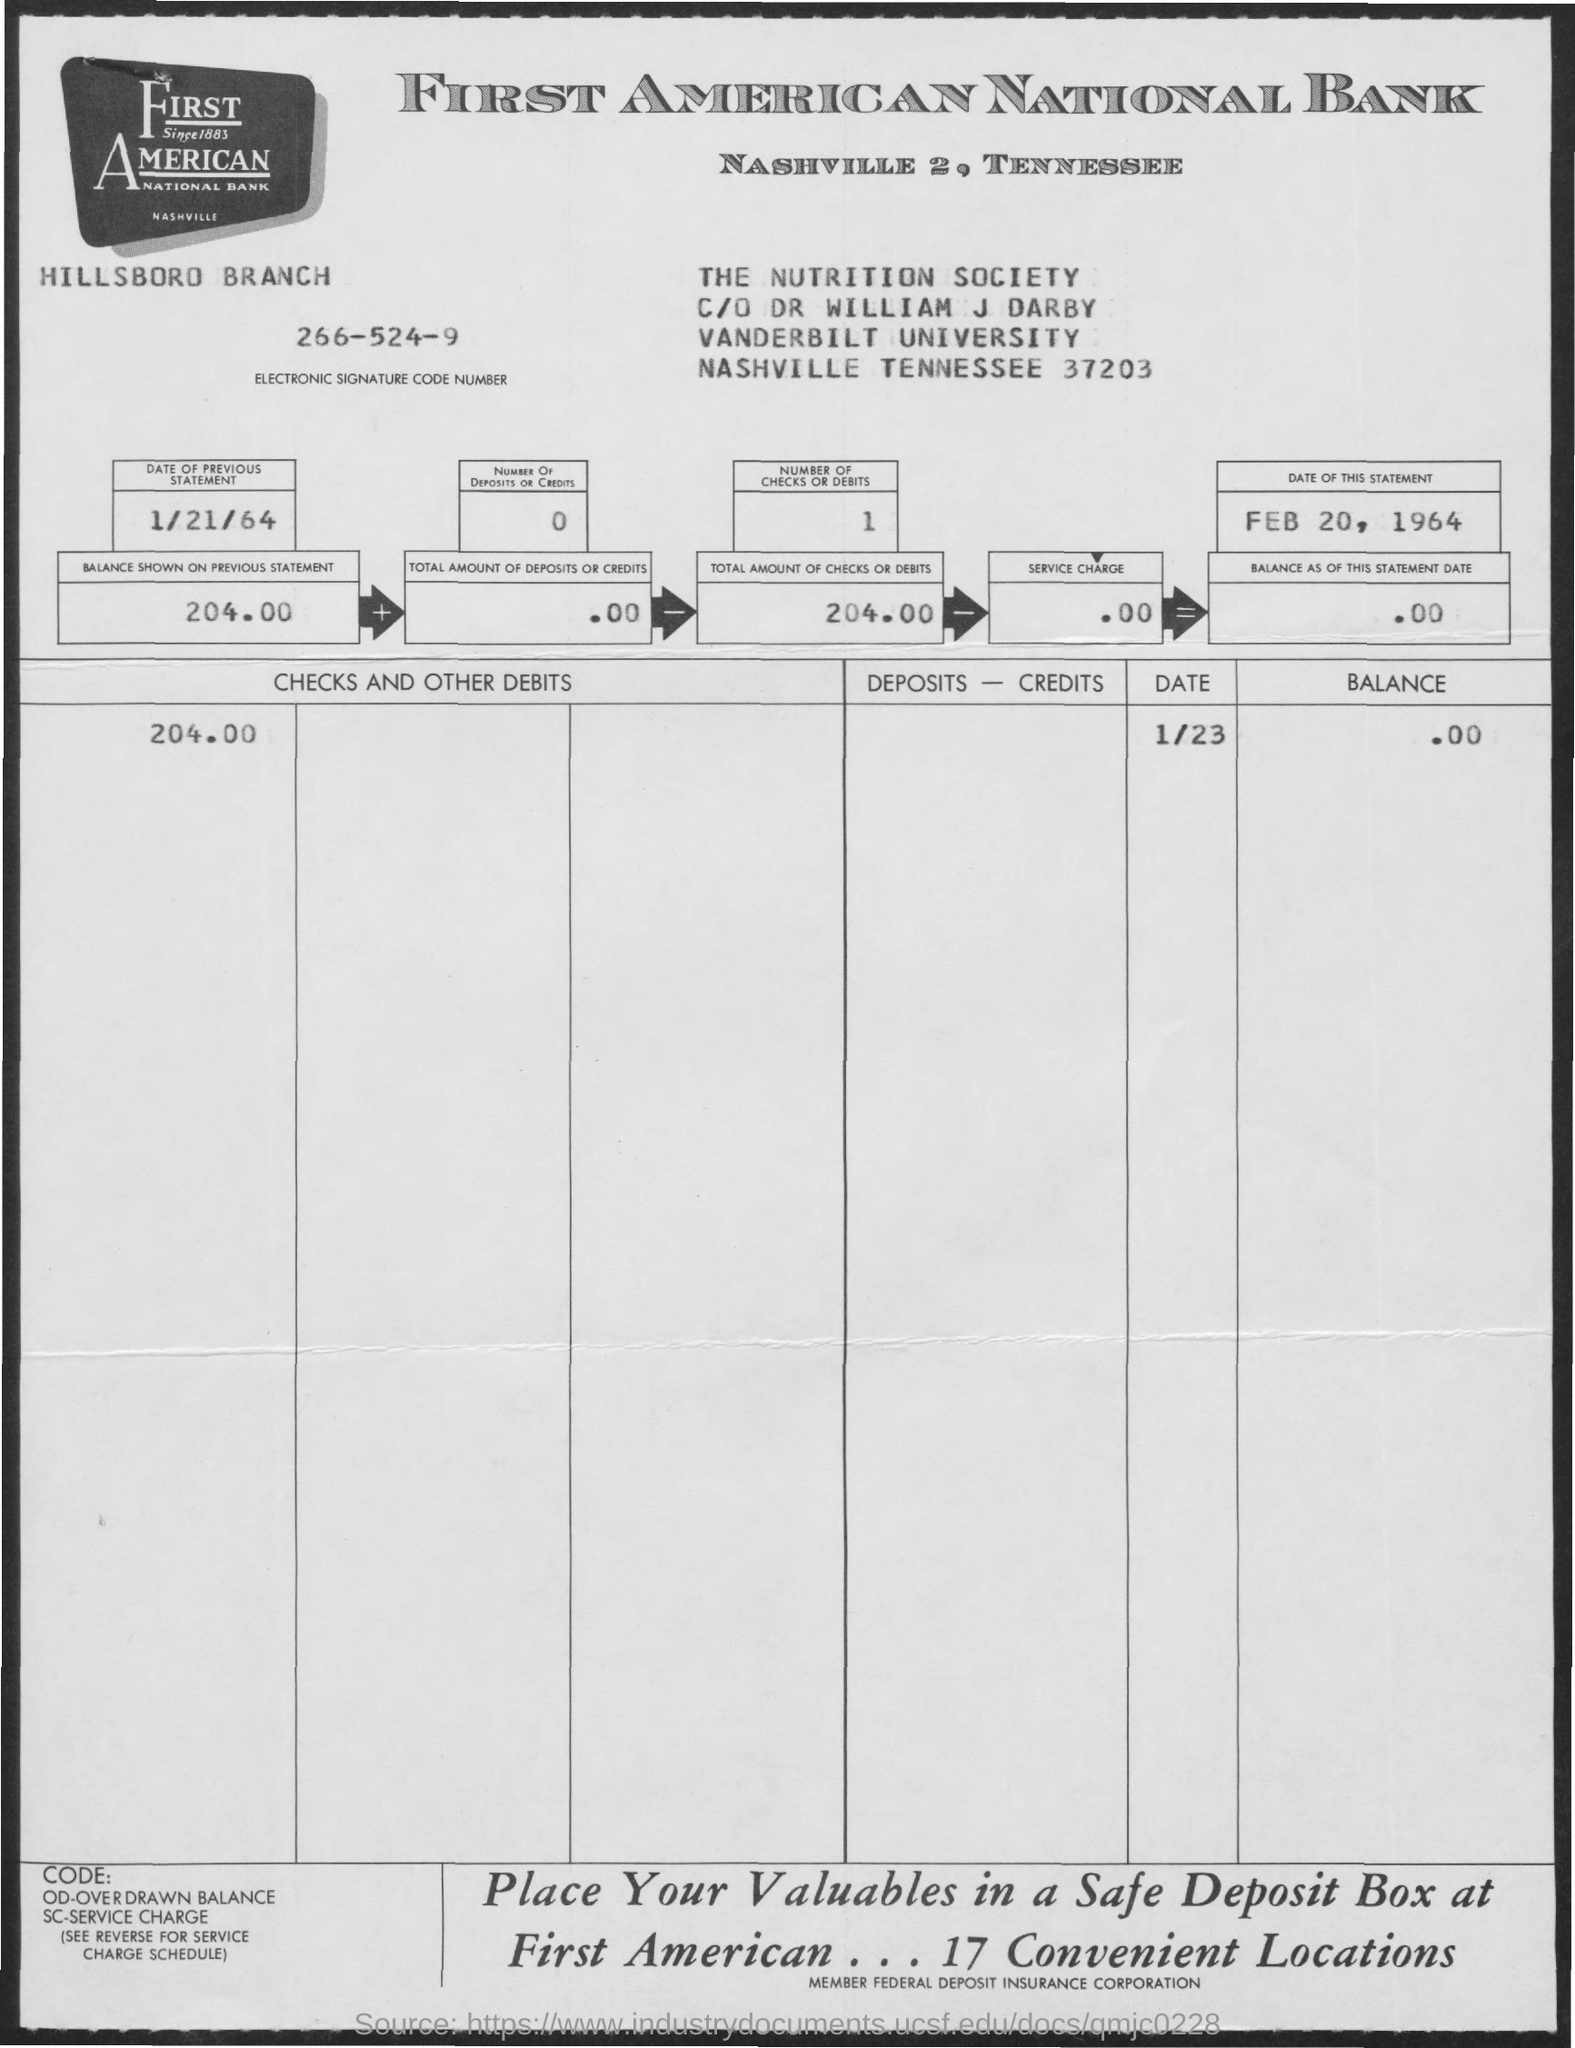What can you deduce about the account's financial activity from the statement? From the bank statement, we can deduce that there has been minimal recent activity. The balance shown on the previous statement was $204.00, and there have been no new deposits or credits, keeping the total amount of deposits or credits at $0.00. The current balance after the latest check or debit of $204.00 remains at $0.00, indicating that the account holder has fully withdrawn or transferred the prior balance. 